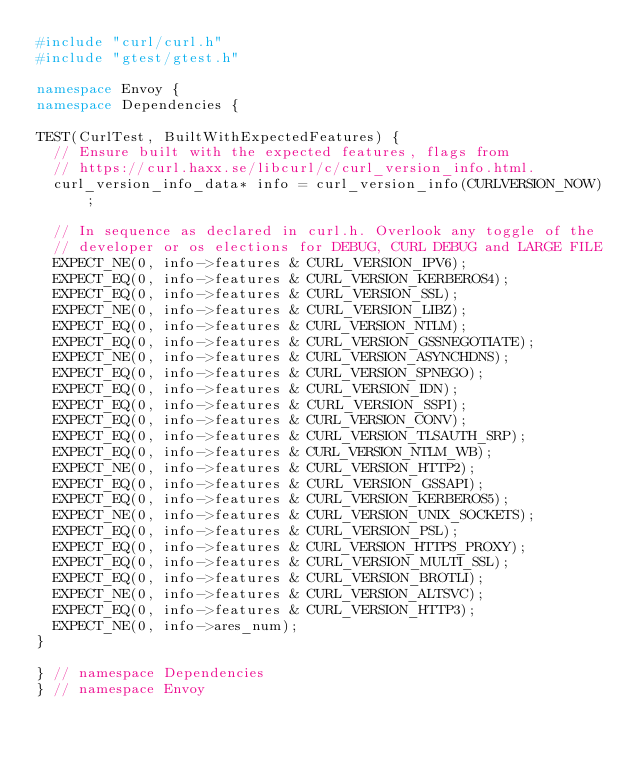<code> <loc_0><loc_0><loc_500><loc_500><_C++_>#include "curl/curl.h"
#include "gtest/gtest.h"

namespace Envoy {
namespace Dependencies {

TEST(CurlTest, BuiltWithExpectedFeatures) {
  // Ensure built with the expected features, flags from
  // https://curl.haxx.se/libcurl/c/curl_version_info.html.
  curl_version_info_data* info = curl_version_info(CURLVERSION_NOW);

  // In sequence as declared in curl.h. Overlook any toggle of the
  // developer or os elections for DEBUG, CURL DEBUG and LARGE FILE
  EXPECT_NE(0, info->features & CURL_VERSION_IPV6);
  EXPECT_EQ(0, info->features & CURL_VERSION_KERBEROS4);
  EXPECT_EQ(0, info->features & CURL_VERSION_SSL);
  EXPECT_NE(0, info->features & CURL_VERSION_LIBZ);
  EXPECT_EQ(0, info->features & CURL_VERSION_NTLM);
  EXPECT_EQ(0, info->features & CURL_VERSION_GSSNEGOTIATE);
  EXPECT_NE(0, info->features & CURL_VERSION_ASYNCHDNS);
  EXPECT_EQ(0, info->features & CURL_VERSION_SPNEGO);
  EXPECT_EQ(0, info->features & CURL_VERSION_IDN);
  EXPECT_EQ(0, info->features & CURL_VERSION_SSPI);
  EXPECT_EQ(0, info->features & CURL_VERSION_CONV);
  EXPECT_EQ(0, info->features & CURL_VERSION_TLSAUTH_SRP);
  EXPECT_EQ(0, info->features & CURL_VERSION_NTLM_WB);
  EXPECT_NE(0, info->features & CURL_VERSION_HTTP2);
  EXPECT_EQ(0, info->features & CURL_VERSION_GSSAPI);
  EXPECT_EQ(0, info->features & CURL_VERSION_KERBEROS5);
  EXPECT_NE(0, info->features & CURL_VERSION_UNIX_SOCKETS);
  EXPECT_EQ(0, info->features & CURL_VERSION_PSL);
  EXPECT_EQ(0, info->features & CURL_VERSION_HTTPS_PROXY);
  EXPECT_EQ(0, info->features & CURL_VERSION_MULTI_SSL);
  EXPECT_EQ(0, info->features & CURL_VERSION_BROTLI);
  EXPECT_NE(0, info->features & CURL_VERSION_ALTSVC);
  EXPECT_EQ(0, info->features & CURL_VERSION_HTTP3);
  EXPECT_NE(0, info->ares_num);
}

} // namespace Dependencies
} // namespace Envoy
</code> 